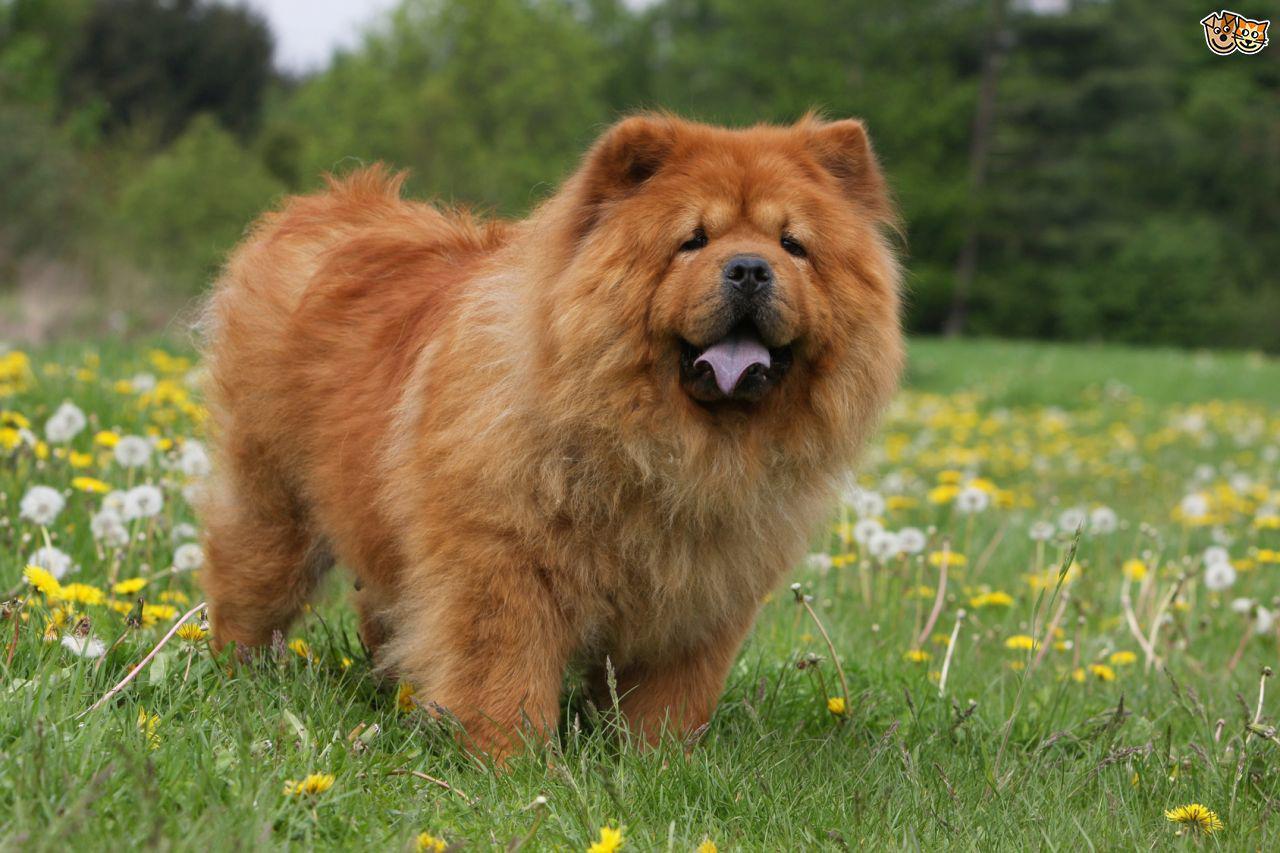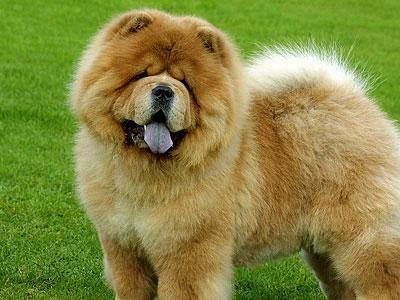The first image is the image on the left, the second image is the image on the right. Analyze the images presented: Is the assertion "The dog in the image on the right has its mouth open" valid? Answer yes or no. Yes. 